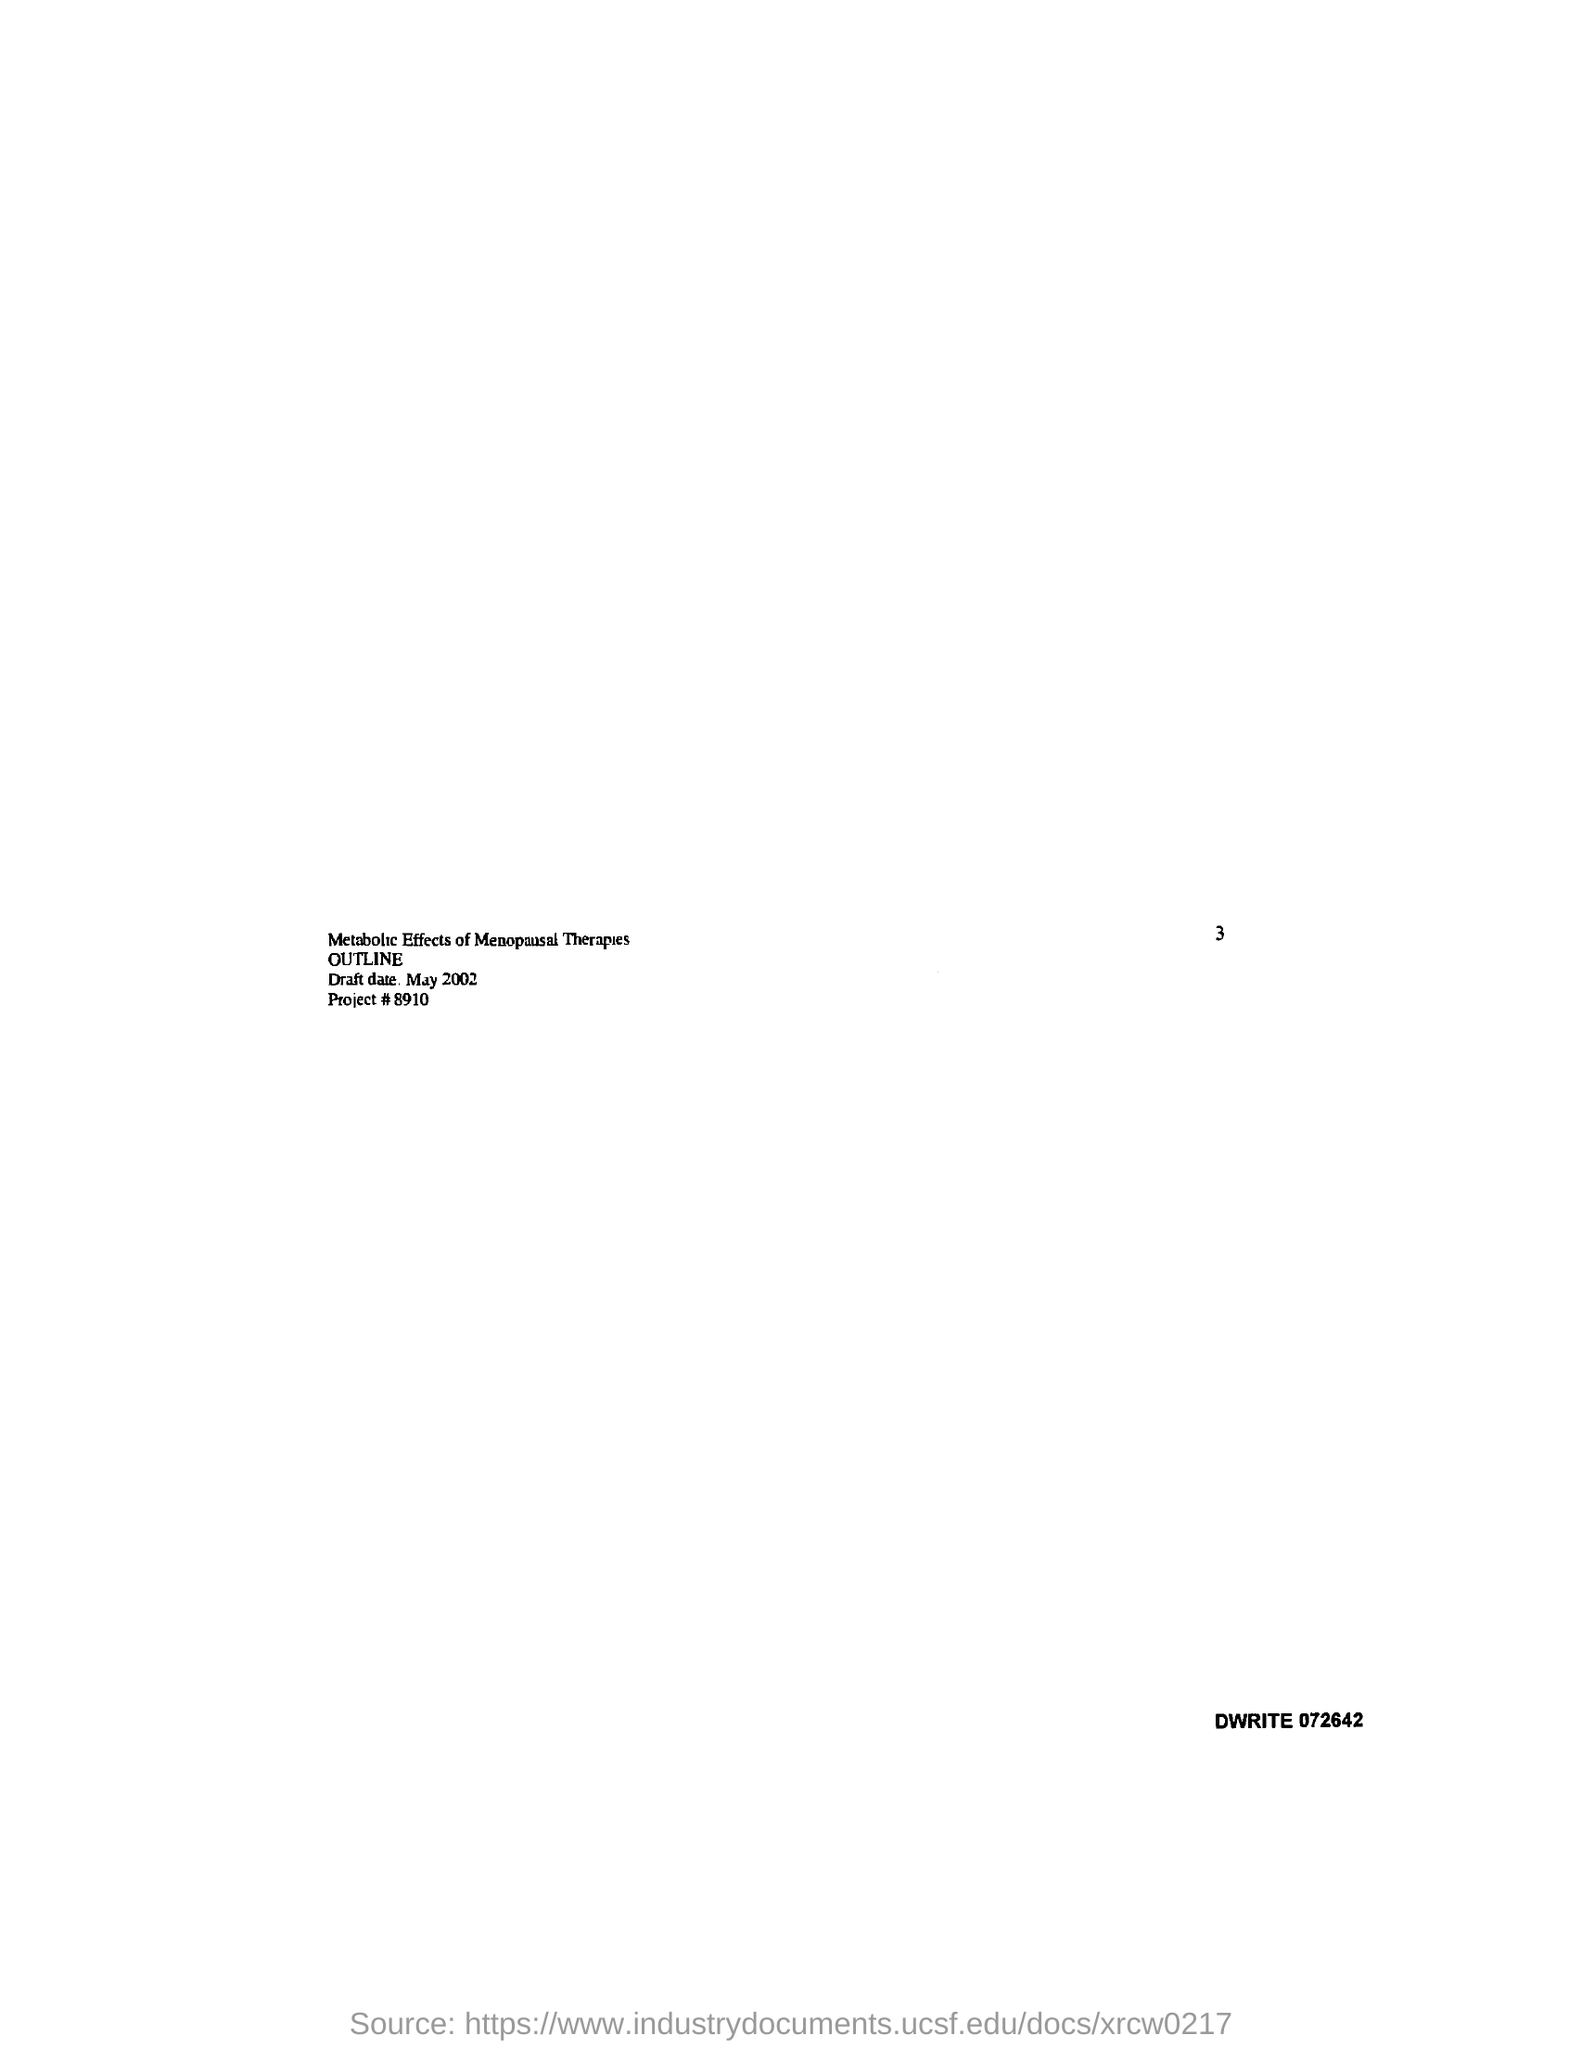What is the title of the draft?
Your answer should be compact. Metabolic Effects of Menopausal Therapies. When is the draft date?
Keep it short and to the point. May 2002. What is the project #?
Offer a terse response. 8910. 